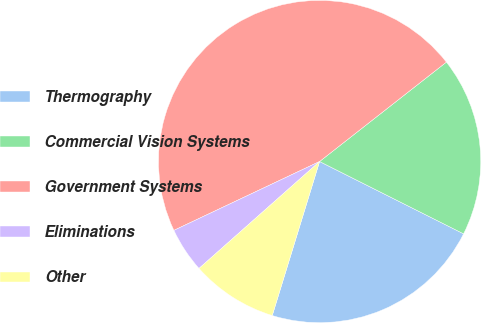<chart> <loc_0><loc_0><loc_500><loc_500><pie_chart><fcel>Thermography<fcel>Commercial Vision Systems<fcel>Government Systems<fcel>Eliminations<fcel>Other<nl><fcel>22.34%<fcel>17.99%<fcel>46.45%<fcel>4.52%<fcel>8.71%<nl></chart> 